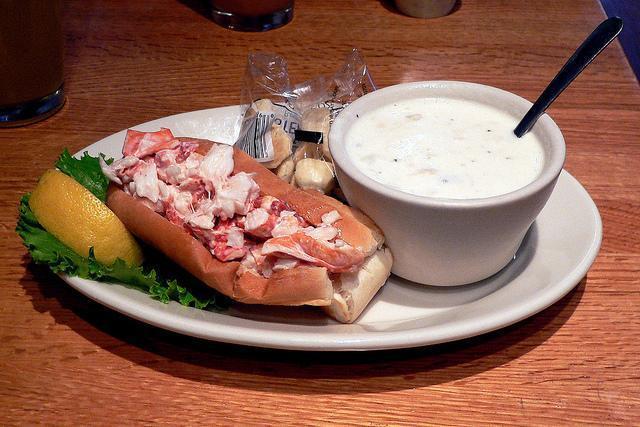How many cups are there?
Give a very brief answer. 3. How many dining tables are there?
Give a very brief answer. 1. How many people posing for picture?
Give a very brief answer. 0. 